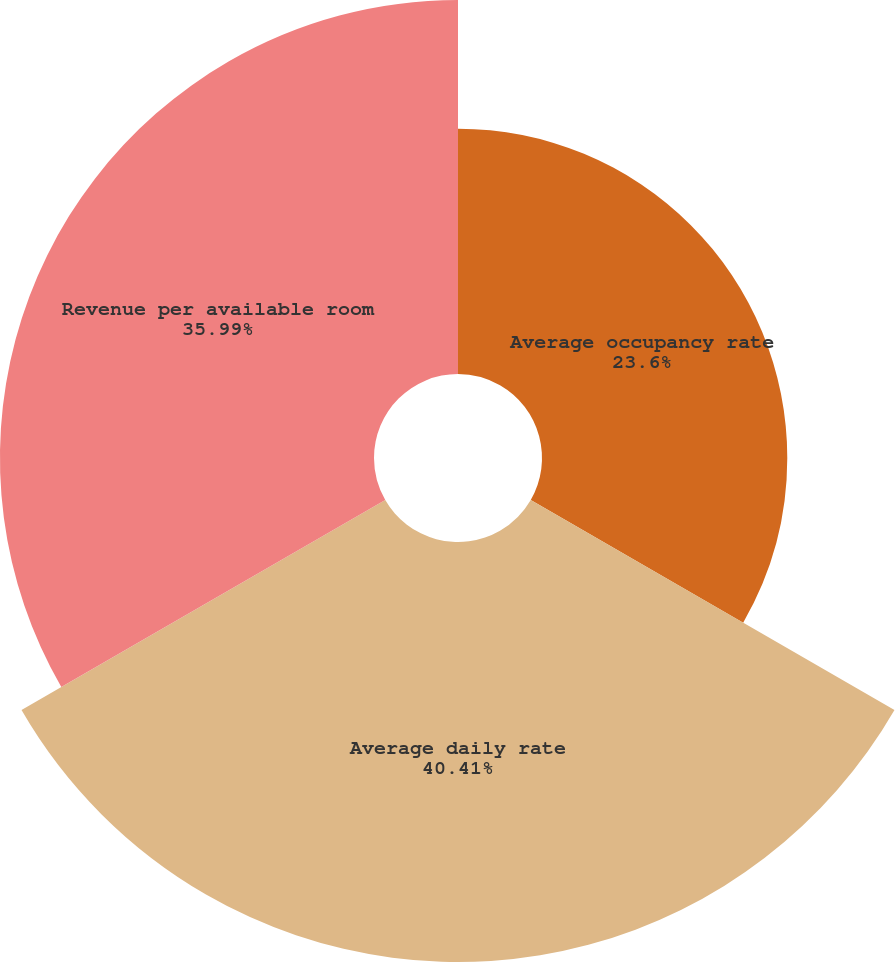Convert chart to OTSL. <chart><loc_0><loc_0><loc_500><loc_500><pie_chart><fcel>Average occupancy rate<fcel>Average daily rate<fcel>Revenue per available room<nl><fcel>23.6%<fcel>40.41%<fcel>35.99%<nl></chart> 